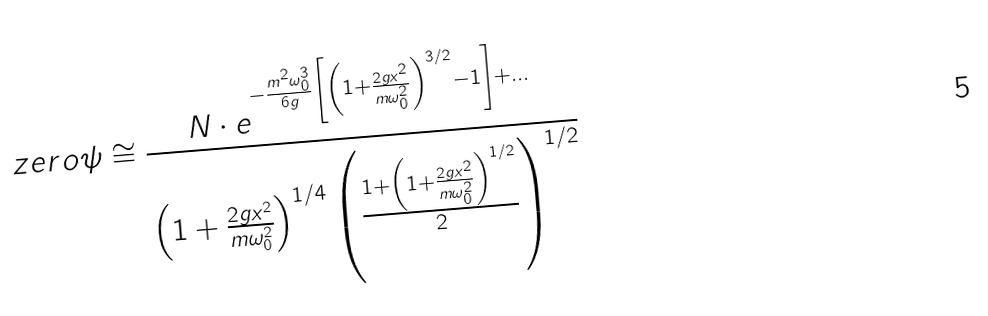Convert formula to latex. <formula><loc_0><loc_0><loc_500><loc_500>\ z e r o { \psi } \cong \frac { N \cdot e ^ { - \frac { m ^ { 2 } \omega _ { 0 } ^ { 3 } } { 6 g } \left [ \left ( 1 + \frac { 2 g x ^ { 2 } } { m \omega _ { 0 } ^ { 2 } } \right ) ^ { 3 / 2 } - 1 \right ] + \dots } } { \left ( 1 + \frac { 2 g x ^ { 2 } } { m \omega _ { 0 } ^ { 2 } } \right ) ^ { 1 / 4 } \left ( \frac { 1 + \left ( 1 + \frac { 2 g x ^ { 2 } } { m \omega _ { 0 } ^ { 2 } } \right ) ^ { 1 / 2 } } { 2 } \right ) ^ { 1 / 2 } }</formula> 